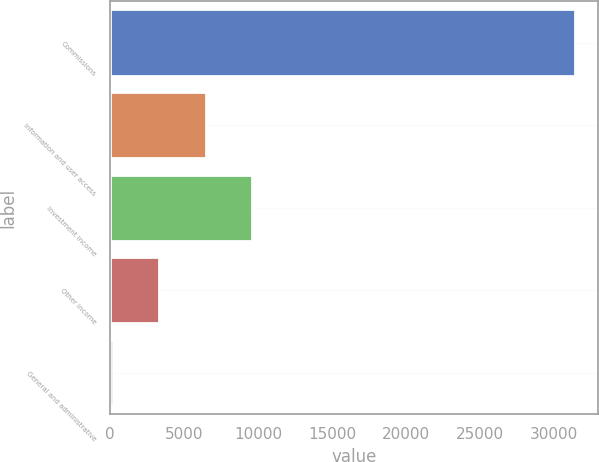<chart> <loc_0><loc_0><loc_500><loc_500><bar_chart><fcel>Commissions<fcel>Information and user access<fcel>Investment income<fcel>Other income<fcel>General and administrative<nl><fcel>31442<fcel>6454<fcel>9577.5<fcel>3330.5<fcel>207<nl></chart> 